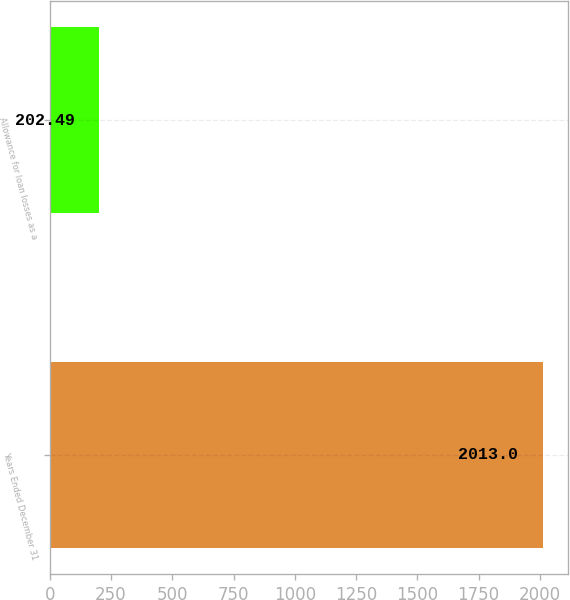Convert chart. <chart><loc_0><loc_0><loc_500><loc_500><bar_chart><fcel>Years Ended December 31<fcel>Allowance for loan losses as a<nl><fcel>2013<fcel>202.49<nl></chart> 